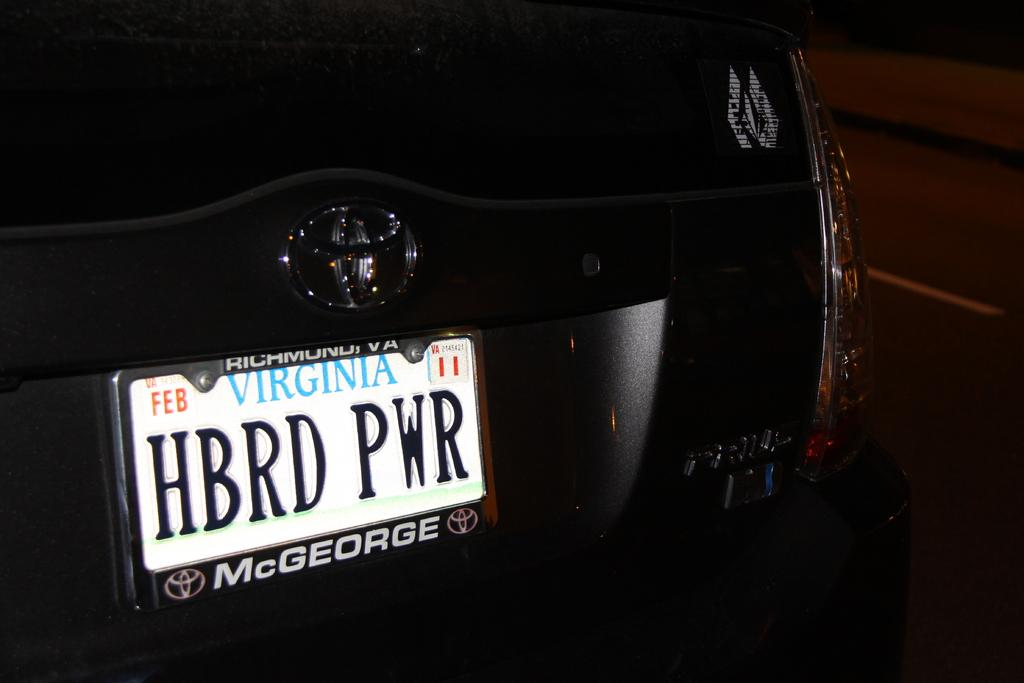<image>
Render a clear and concise summary of the photo. Virginia license plate which says HBRD PWR on the back. 